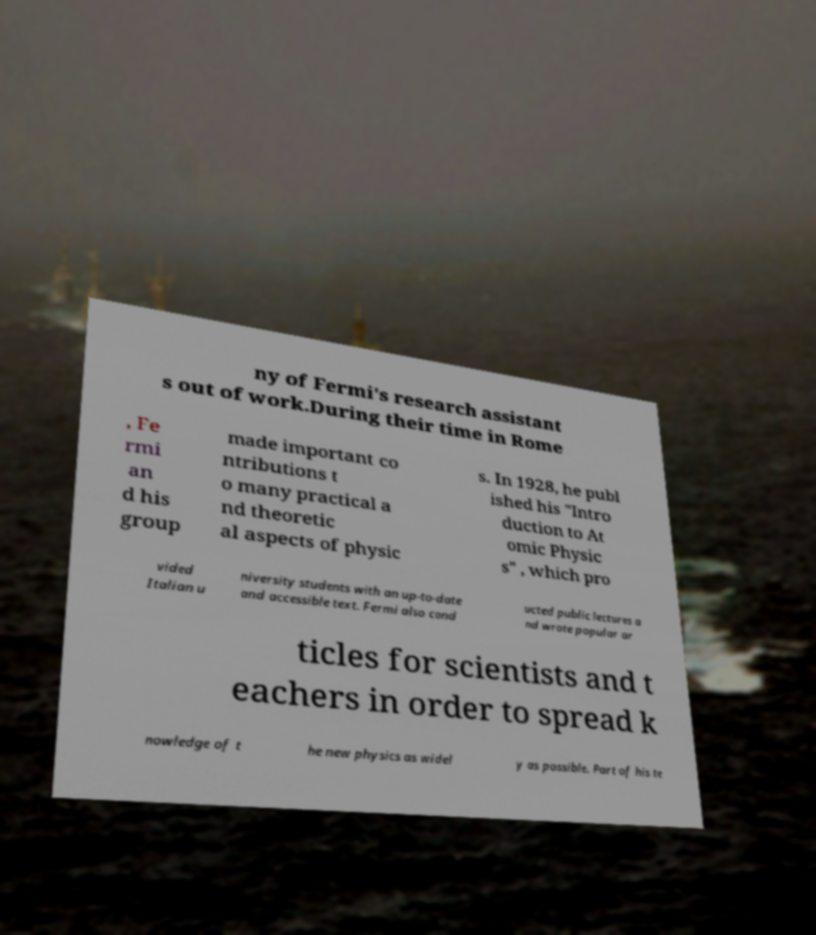Could you extract and type out the text from this image? ny of Fermi's research assistant s out of work.During their time in Rome , Fe rmi an d his group made important co ntributions t o many practical a nd theoretic al aspects of physic s. In 1928, he publ ished his "Intro duction to At omic Physic s" , which pro vided Italian u niversity students with an up-to-date and accessible text. Fermi also cond ucted public lectures a nd wrote popular ar ticles for scientists and t eachers in order to spread k nowledge of t he new physics as widel y as possible. Part of his te 